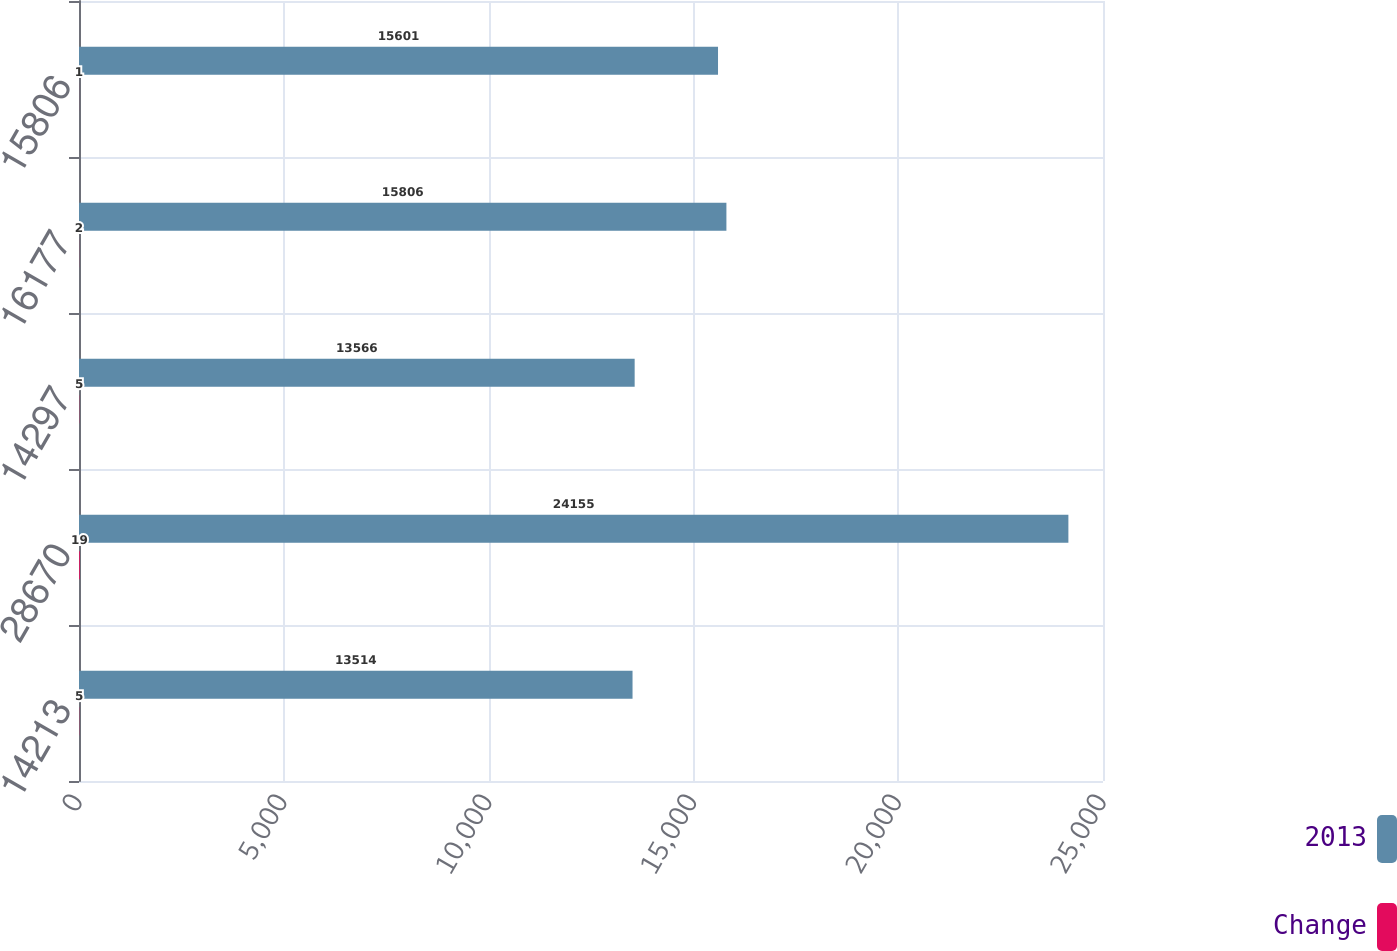Convert chart. <chart><loc_0><loc_0><loc_500><loc_500><stacked_bar_chart><ecel><fcel>14213<fcel>28670<fcel>14297<fcel>16177<fcel>15806<nl><fcel>2013<fcel>13514<fcel>24155<fcel>13566<fcel>15806<fcel>15601<nl><fcel>Change<fcel>5<fcel>19<fcel>5<fcel>2<fcel>1<nl></chart> 